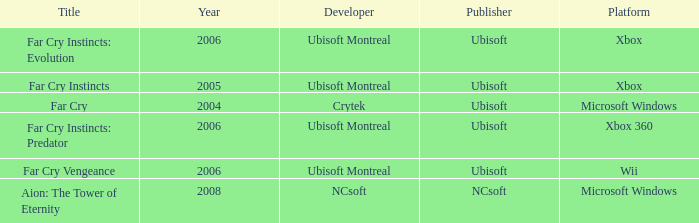Which developer has xbox 360 as the platform? Ubisoft Montreal. 